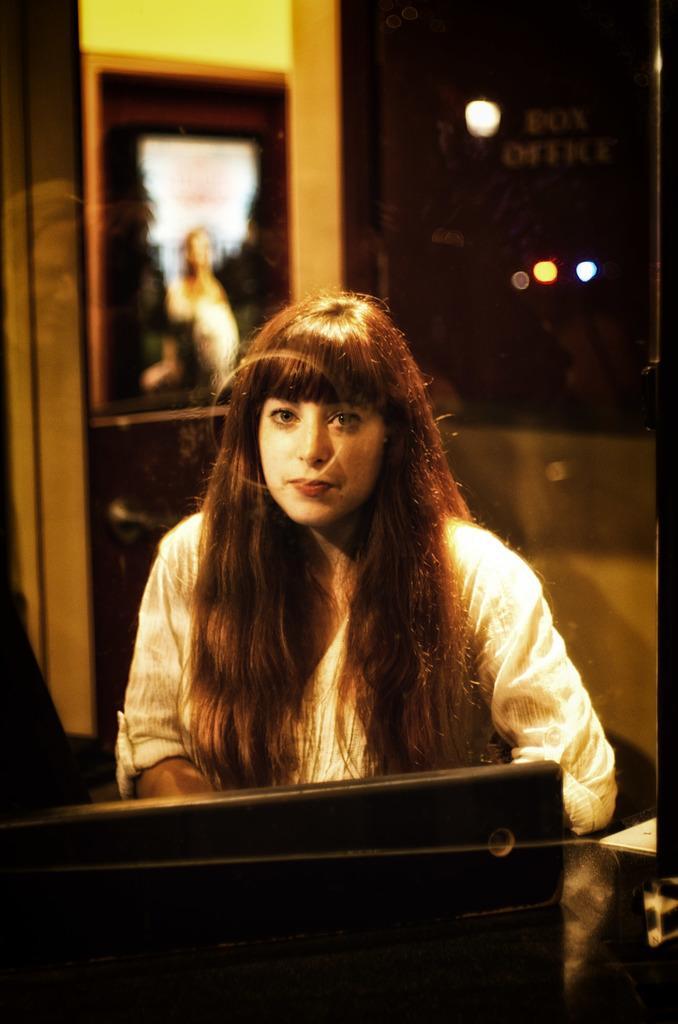Can you describe this image briefly? In this image in the center there is a woman sitting and in front of the woman there is an object which is black in colour and the background is blurry. 